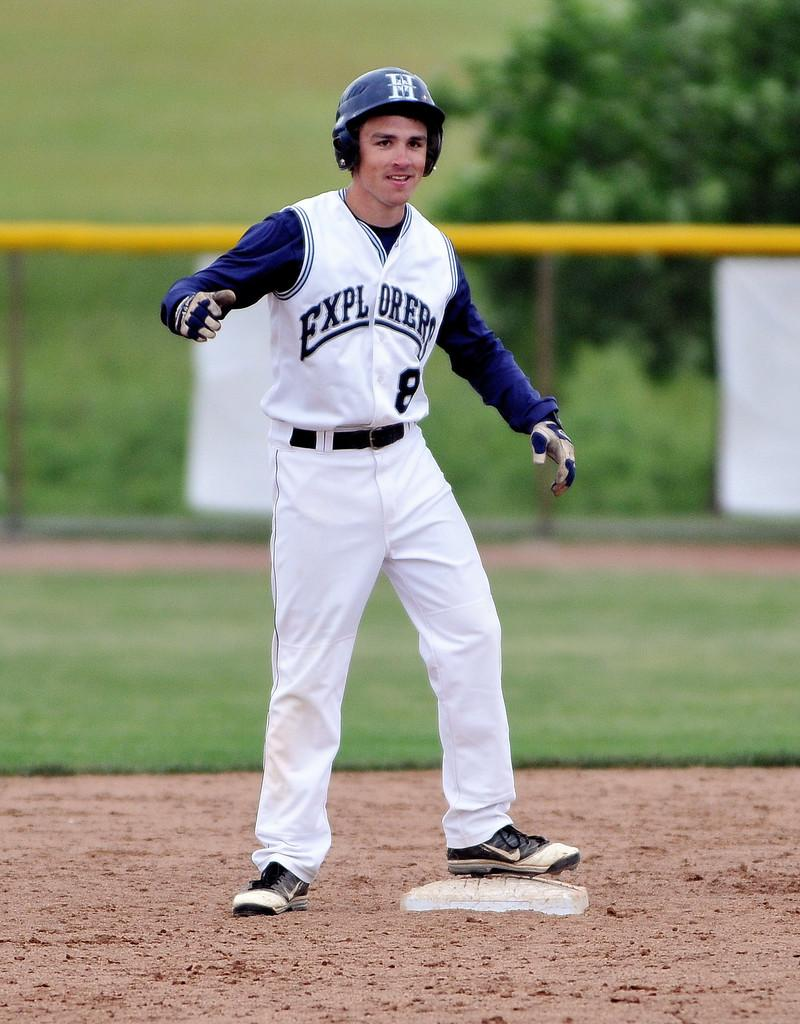<image>
Describe the image concisely. an explorers player on second base with a smile 